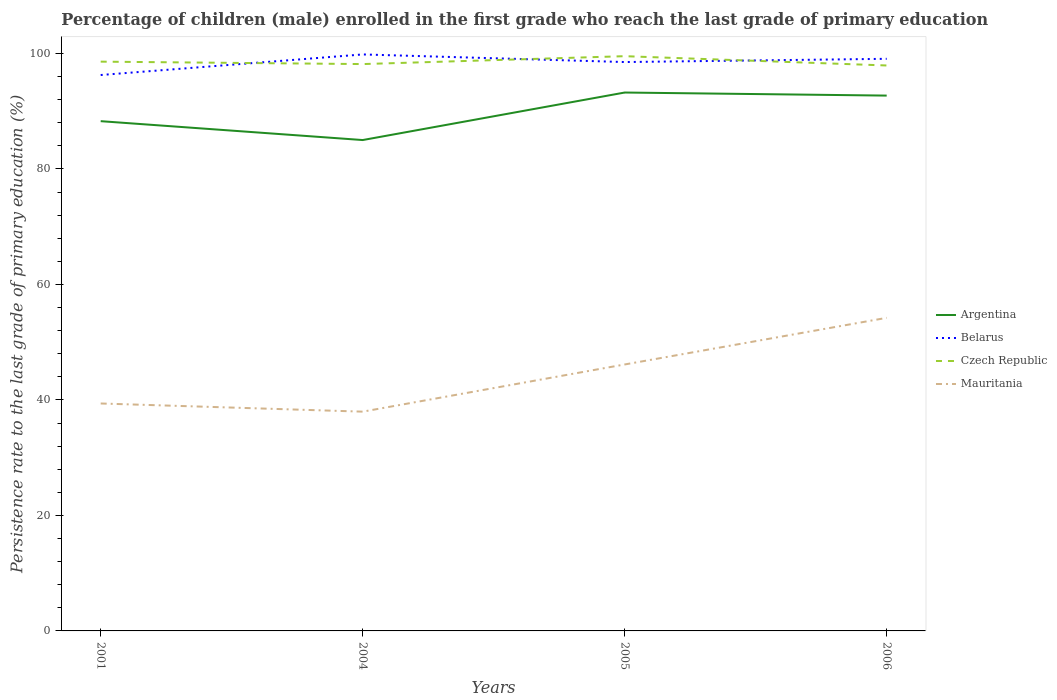How many different coloured lines are there?
Your response must be concise. 4. Does the line corresponding to Czech Republic intersect with the line corresponding to Argentina?
Your answer should be very brief. No. Across all years, what is the maximum persistence rate of children in Belarus?
Your response must be concise. 96.27. In which year was the persistence rate of children in Argentina maximum?
Offer a terse response. 2004. What is the total persistence rate of children in Argentina in the graph?
Your answer should be compact. -7.7. What is the difference between the highest and the second highest persistence rate of children in Mauritania?
Give a very brief answer. 16.25. What is the difference between the highest and the lowest persistence rate of children in Belarus?
Offer a very short reply. 3. How many lines are there?
Your response must be concise. 4. What is the difference between two consecutive major ticks on the Y-axis?
Give a very brief answer. 20. Does the graph contain any zero values?
Your answer should be very brief. No. Does the graph contain grids?
Offer a terse response. No. How many legend labels are there?
Keep it short and to the point. 4. What is the title of the graph?
Provide a short and direct response. Percentage of children (male) enrolled in the first grade who reach the last grade of primary education. Does "Japan" appear as one of the legend labels in the graph?
Provide a succinct answer. No. What is the label or title of the X-axis?
Provide a succinct answer. Years. What is the label or title of the Y-axis?
Provide a succinct answer. Persistence rate to the last grade of primary education (%). What is the Persistence rate to the last grade of primary education (%) of Argentina in 2001?
Offer a very short reply. 88.28. What is the Persistence rate to the last grade of primary education (%) in Belarus in 2001?
Provide a short and direct response. 96.27. What is the Persistence rate to the last grade of primary education (%) of Czech Republic in 2001?
Provide a succinct answer. 98.59. What is the Persistence rate to the last grade of primary education (%) of Mauritania in 2001?
Your answer should be very brief. 39.39. What is the Persistence rate to the last grade of primary education (%) in Argentina in 2004?
Your answer should be very brief. 85.01. What is the Persistence rate to the last grade of primary education (%) in Belarus in 2004?
Your answer should be compact. 99.84. What is the Persistence rate to the last grade of primary education (%) in Czech Republic in 2004?
Make the answer very short. 98.17. What is the Persistence rate to the last grade of primary education (%) of Mauritania in 2004?
Make the answer very short. 37.97. What is the Persistence rate to the last grade of primary education (%) in Argentina in 2005?
Ensure brevity in your answer.  93.24. What is the Persistence rate to the last grade of primary education (%) of Belarus in 2005?
Give a very brief answer. 98.52. What is the Persistence rate to the last grade of primary education (%) of Czech Republic in 2005?
Your response must be concise. 99.53. What is the Persistence rate to the last grade of primary education (%) in Mauritania in 2005?
Offer a very short reply. 46.14. What is the Persistence rate to the last grade of primary education (%) in Argentina in 2006?
Your answer should be very brief. 92.71. What is the Persistence rate to the last grade of primary education (%) in Belarus in 2006?
Your answer should be very brief. 99.08. What is the Persistence rate to the last grade of primary education (%) of Czech Republic in 2006?
Your answer should be compact. 97.92. What is the Persistence rate to the last grade of primary education (%) of Mauritania in 2006?
Your answer should be compact. 54.22. Across all years, what is the maximum Persistence rate to the last grade of primary education (%) of Argentina?
Provide a succinct answer. 93.24. Across all years, what is the maximum Persistence rate to the last grade of primary education (%) in Belarus?
Your response must be concise. 99.84. Across all years, what is the maximum Persistence rate to the last grade of primary education (%) of Czech Republic?
Make the answer very short. 99.53. Across all years, what is the maximum Persistence rate to the last grade of primary education (%) of Mauritania?
Your answer should be very brief. 54.22. Across all years, what is the minimum Persistence rate to the last grade of primary education (%) of Argentina?
Provide a succinct answer. 85.01. Across all years, what is the minimum Persistence rate to the last grade of primary education (%) in Belarus?
Offer a very short reply. 96.27. Across all years, what is the minimum Persistence rate to the last grade of primary education (%) of Czech Republic?
Offer a terse response. 97.92. Across all years, what is the minimum Persistence rate to the last grade of primary education (%) in Mauritania?
Offer a terse response. 37.97. What is the total Persistence rate to the last grade of primary education (%) in Argentina in the graph?
Offer a terse response. 359.23. What is the total Persistence rate to the last grade of primary education (%) in Belarus in the graph?
Make the answer very short. 393.7. What is the total Persistence rate to the last grade of primary education (%) of Czech Republic in the graph?
Offer a very short reply. 394.21. What is the total Persistence rate to the last grade of primary education (%) in Mauritania in the graph?
Offer a terse response. 177.73. What is the difference between the Persistence rate to the last grade of primary education (%) in Argentina in 2001 and that in 2004?
Ensure brevity in your answer.  3.27. What is the difference between the Persistence rate to the last grade of primary education (%) of Belarus in 2001 and that in 2004?
Offer a terse response. -3.56. What is the difference between the Persistence rate to the last grade of primary education (%) in Czech Republic in 2001 and that in 2004?
Offer a terse response. 0.42. What is the difference between the Persistence rate to the last grade of primary education (%) in Mauritania in 2001 and that in 2004?
Provide a short and direct response. 1.41. What is the difference between the Persistence rate to the last grade of primary education (%) in Argentina in 2001 and that in 2005?
Give a very brief answer. -4.96. What is the difference between the Persistence rate to the last grade of primary education (%) of Belarus in 2001 and that in 2005?
Provide a short and direct response. -2.25. What is the difference between the Persistence rate to the last grade of primary education (%) of Czech Republic in 2001 and that in 2005?
Provide a short and direct response. -0.95. What is the difference between the Persistence rate to the last grade of primary education (%) of Mauritania in 2001 and that in 2005?
Offer a very short reply. -6.76. What is the difference between the Persistence rate to the last grade of primary education (%) in Argentina in 2001 and that in 2006?
Your answer should be very brief. -4.43. What is the difference between the Persistence rate to the last grade of primary education (%) in Belarus in 2001 and that in 2006?
Ensure brevity in your answer.  -2.81. What is the difference between the Persistence rate to the last grade of primary education (%) of Czech Republic in 2001 and that in 2006?
Give a very brief answer. 0.66. What is the difference between the Persistence rate to the last grade of primary education (%) of Mauritania in 2001 and that in 2006?
Your answer should be very brief. -14.83. What is the difference between the Persistence rate to the last grade of primary education (%) in Argentina in 2004 and that in 2005?
Offer a very short reply. -8.23. What is the difference between the Persistence rate to the last grade of primary education (%) in Belarus in 2004 and that in 2005?
Keep it short and to the point. 1.32. What is the difference between the Persistence rate to the last grade of primary education (%) of Czech Republic in 2004 and that in 2005?
Keep it short and to the point. -1.37. What is the difference between the Persistence rate to the last grade of primary education (%) of Mauritania in 2004 and that in 2005?
Offer a very short reply. -8.17. What is the difference between the Persistence rate to the last grade of primary education (%) in Argentina in 2004 and that in 2006?
Give a very brief answer. -7.7. What is the difference between the Persistence rate to the last grade of primary education (%) in Belarus in 2004 and that in 2006?
Give a very brief answer. 0.76. What is the difference between the Persistence rate to the last grade of primary education (%) of Czech Republic in 2004 and that in 2006?
Offer a terse response. 0.24. What is the difference between the Persistence rate to the last grade of primary education (%) in Mauritania in 2004 and that in 2006?
Offer a very short reply. -16.25. What is the difference between the Persistence rate to the last grade of primary education (%) in Argentina in 2005 and that in 2006?
Your answer should be very brief. 0.53. What is the difference between the Persistence rate to the last grade of primary education (%) of Belarus in 2005 and that in 2006?
Keep it short and to the point. -0.56. What is the difference between the Persistence rate to the last grade of primary education (%) in Czech Republic in 2005 and that in 2006?
Offer a terse response. 1.61. What is the difference between the Persistence rate to the last grade of primary education (%) in Mauritania in 2005 and that in 2006?
Make the answer very short. -8.08. What is the difference between the Persistence rate to the last grade of primary education (%) of Argentina in 2001 and the Persistence rate to the last grade of primary education (%) of Belarus in 2004?
Offer a very short reply. -11.56. What is the difference between the Persistence rate to the last grade of primary education (%) of Argentina in 2001 and the Persistence rate to the last grade of primary education (%) of Czech Republic in 2004?
Keep it short and to the point. -9.89. What is the difference between the Persistence rate to the last grade of primary education (%) of Argentina in 2001 and the Persistence rate to the last grade of primary education (%) of Mauritania in 2004?
Provide a succinct answer. 50.3. What is the difference between the Persistence rate to the last grade of primary education (%) of Belarus in 2001 and the Persistence rate to the last grade of primary education (%) of Czech Republic in 2004?
Your answer should be very brief. -1.89. What is the difference between the Persistence rate to the last grade of primary education (%) of Belarus in 2001 and the Persistence rate to the last grade of primary education (%) of Mauritania in 2004?
Your answer should be very brief. 58.3. What is the difference between the Persistence rate to the last grade of primary education (%) in Czech Republic in 2001 and the Persistence rate to the last grade of primary education (%) in Mauritania in 2004?
Keep it short and to the point. 60.61. What is the difference between the Persistence rate to the last grade of primary education (%) in Argentina in 2001 and the Persistence rate to the last grade of primary education (%) in Belarus in 2005?
Your answer should be very brief. -10.24. What is the difference between the Persistence rate to the last grade of primary education (%) of Argentina in 2001 and the Persistence rate to the last grade of primary education (%) of Czech Republic in 2005?
Make the answer very short. -11.26. What is the difference between the Persistence rate to the last grade of primary education (%) of Argentina in 2001 and the Persistence rate to the last grade of primary education (%) of Mauritania in 2005?
Ensure brevity in your answer.  42.13. What is the difference between the Persistence rate to the last grade of primary education (%) in Belarus in 2001 and the Persistence rate to the last grade of primary education (%) in Czech Republic in 2005?
Your answer should be compact. -3.26. What is the difference between the Persistence rate to the last grade of primary education (%) in Belarus in 2001 and the Persistence rate to the last grade of primary education (%) in Mauritania in 2005?
Offer a very short reply. 50.13. What is the difference between the Persistence rate to the last grade of primary education (%) in Czech Republic in 2001 and the Persistence rate to the last grade of primary education (%) in Mauritania in 2005?
Provide a short and direct response. 52.44. What is the difference between the Persistence rate to the last grade of primary education (%) in Argentina in 2001 and the Persistence rate to the last grade of primary education (%) in Belarus in 2006?
Provide a short and direct response. -10.8. What is the difference between the Persistence rate to the last grade of primary education (%) in Argentina in 2001 and the Persistence rate to the last grade of primary education (%) in Czech Republic in 2006?
Offer a very short reply. -9.65. What is the difference between the Persistence rate to the last grade of primary education (%) of Argentina in 2001 and the Persistence rate to the last grade of primary education (%) of Mauritania in 2006?
Make the answer very short. 34.06. What is the difference between the Persistence rate to the last grade of primary education (%) in Belarus in 2001 and the Persistence rate to the last grade of primary education (%) in Czech Republic in 2006?
Make the answer very short. -1.65. What is the difference between the Persistence rate to the last grade of primary education (%) in Belarus in 2001 and the Persistence rate to the last grade of primary education (%) in Mauritania in 2006?
Your answer should be compact. 42.05. What is the difference between the Persistence rate to the last grade of primary education (%) in Czech Republic in 2001 and the Persistence rate to the last grade of primary education (%) in Mauritania in 2006?
Provide a succinct answer. 44.37. What is the difference between the Persistence rate to the last grade of primary education (%) of Argentina in 2004 and the Persistence rate to the last grade of primary education (%) of Belarus in 2005?
Provide a short and direct response. -13.51. What is the difference between the Persistence rate to the last grade of primary education (%) of Argentina in 2004 and the Persistence rate to the last grade of primary education (%) of Czech Republic in 2005?
Provide a succinct answer. -14.52. What is the difference between the Persistence rate to the last grade of primary education (%) of Argentina in 2004 and the Persistence rate to the last grade of primary education (%) of Mauritania in 2005?
Provide a succinct answer. 38.86. What is the difference between the Persistence rate to the last grade of primary education (%) in Belarus in 2004 and the Persistence rate to the last grade of primary education (%) in Czech Republic in 2005?
Provide a short and direct response. 0.3. What is the difference between the Persistence rate to the last grade of primary education (%) in Belarus in 2004 and the Persistence rate to the last grade of primary education (%) in Mauritania in 2005?
Your answer should be compact. 53.69. What is the difference between the Persistence rate to the last grade of primary education (%) in Czech Republic in 2004 and the Persistence rate to the last grade of primary education (%) in Mauritania in 2005?
Your response must be concise. 52.02. What is the difference between the Persistence rate to the last grade of primary education (%) in Argentina in 2004 and the Persistence rate to the last grade of primary education (%) in Belarus in 2006?
Give a very brief answer. -14.07. What is the difference between the Persistence rate to the last grade of primary education (%) of Argentina in 2004 and the Persistence rate to the last grade of primary education (%) of Czech Republic in 2006?
Your answer should be very brief. -12.91. What is the difference between the Persistence rate to the last grade of primary education (%) of Argentina in 2004 and the Persistence rate to the last grade of primary education (%) of Mauritania in 2006?
Keep it short and to the point. 30.79. What is the difference between the Persistence rate to the last grade of primary education (%) of Belarus in 2004 and the Persistence rate to the last grade of primary education (%) of Czech Republic in 2006?
Offer a very short reply. 1.91. What is the difference between the Persistence rate to the last grade of primary education (%) in Belarus in 2004 and the Persistence rate to the last grade of primary education (%) in Mauritania in 2006?
Provide a short and direct response. 45.61. What is the difference between the Persistence rate to the last grade of primary education (%) in Czech Republic in 2004 and the Persistence rate to the last grade of primary education (%) in Mauritania in 2006?
Your response must be concise. 43.95. What is the difference between the Persistence rate to the last grade of primary education (%) in Argentina in 2005 and the Persistence rate to the last grade of primary education (%) in Belarus in 2006?
Offer a very short reply. -5.84. What is the difference between the Persistence rate to the last grade of primary education (%) in Argentina in 2005 and the Persistence rate to the last grade of primary education (%) in Czech Republic in 2006?
Keep it short and to the point. -4.68. What is the difference between the Persistence rate to the last grade of primary education (%) of Argentina in 2005 and the Persistence rate to the last grade of primary education (%) of Mauritania in 2006?
Your answer should be very brief. 39.02. What is the difference between the Persistence rate to the last grade of primary education (%) in Belarus in 2005 and the Persistence rate to the last grade of primary education (%) in Czech Republic in 2006?
Ensure brevity in your answer.  0.59. What is the difference between the Persistence rate to the last grade of primary education (%) in Belarus in 2005 and the Persistence rate to the last grade of primary education (%) in Mauritania in 2006?
Your response must be concise. 44.3. What is the difference between the Persistence rate to the last grade of primary education (%) of Czech Republic in 2005 and the Persistence rate to the last grade of primary education (%) of Mauritania in 2006?
Offer a terse response. 45.31. What is the average Persistence rate to the last grade of primary education (%) in Argentina per year?
Offer a terse response. 89.81. What is the average Persistence rate to the last grade of primary education (%) of Belarus per year?
Ensure brevity in your answer.  98.43. What is the average Persistence rate to the last grade of primary education (%) of Czech Republic per year?
Your response must be concise. 98.55. What is the average Persistence rate to the last grade of primary education (%) of Mauritania per year?
Offer a terse response. 44.43. In the year 2001, what is the difference between the Persistence rate to the last grade of primary education (%) in Argentina and Persistence rate to the last grade of primary education (%) in Belarus?
Your response must be concise. -7.99. In the year 2001, what is the difference between the Persistence rate to the last grade of primary education (%) in Argentina and Persistence rate to the last grade of primary education (%) in Czech Republic?
Your answer should be very brief. -10.31. In the year 2001, what is the difference between the Persistence rate to the last grade of primary education (%) of Argentina and Persistence rate to the last grade of primary education (%) of Mauritania?
Provide a succinct answer. 48.89. In the year 2001, what is the difference between the Persistence rate to the last grade of primary education (%) of Belarus and Persistence rate to the last grade of primary education (%) of Czech Republic?
Provide a short and direct response. -2.31. In the year 2001, what is the difference between the Persistence rate to the last grade of primary education (%) of Belarus and Persistence rate to the last grade of primary education (%) of Mauritania?
Give a very brief answer. 56.88. In the year 2001, what is the difference between the Persistence rate to the last grade of primary education (%) of Czech Republic and Persistence rate to the last grade of primary education (%) of Mauritania?
Your answer should be very brief. 59.2. In the year 2004, what is the difference between the Persistence rate to the last grade of primary education (%) in Argentina and Persistence rate to the last grade of primary education (%) in Belarus?
Provide a succinct answer. -14.83. In the year 2004, what is the difference between the Persistence rate to the last grade of primary education (%) in Argentina and Persistence rate to the last grade of primary education (%) in Czech Republic?
Your answer should be compact. -13.16. In the year 2004, what is the difference between the Persistence rate to the last grade of primary education (%) of Argentina and Persistence rate to the last grade of primary education (%) of Mauritania?
Give a very brief answer. 47.04. In the year 2004, what is the difference between the Persistence rate to the last grade of primary education (%) in Belarus and Persistence rate to the last grade of primary education (%) in Czech Republic?
Offer a terse response. 1.67. In the year 2004, what is the difference between the Persistence rate to the last grade of primary education (%) of Belarus and Persistence rate to the last grade of primary education (%) of Mauritania?
Your response must be concise. 61.86. In the year 2004, what is the difference between the Persistence rate to the last grade of primary education (%) of Czech Republic and Persistence rate to the last grade of primary education (%) of Mauritania?
Provide a short and direct response. 60.19. In the year 2005, what is the difference between the Persistence rate to the last grade of primary education (%) in Argentina and Persistence rate to the last grade of primary education (%) in Belarus?
Offer a very short reply. -5.28. In the year 2005, what is the difference between the Persistence rate to the last grade of primary education (%) in Argentina and Persistence rate to the last grade of primary education (%) in Czech Republic?
Your answer should be compact. -6.3. In the year 2005, what is the difference between the Persistence rate to the last grade of primary education (%) in Argentina and Persistence rate to the last grade of primary education (%) in Mauritania?
Keep it short and to the point. 47.09. In the year 2005, what is the difference between the Persistence rate to the last grade of primary education (%) of Belarus and Persistence rate to the last grade of primary education (%) of Czech Republic?
Give a very brief answer. -1.02. In the year 2005, what is the difference between the Persistence rate to the last grade of primary education (%) in Belarus and Persistence rate to the last grade of primary education (%) in Mauritania?
Offer a terse response. 52.37. In the year 2005, what is the difference between the Persistence rate to the last grade of primary education (%) in Czech Republic and Persistence rate to the last grade of primary education (%) in Mauritania?
Your response must be concise. 53.39. In the year 2006, what is the difference between the Persistence rate to the last grade of primary education (%) of Argentina and Persistence rate to the last grade of primary education (%) of Belarus?
Offer a very short reply. -6.37. In the year 2006, what is the difference between the Persistence rate to the last grade of primary education (%) in Argentina and Persistence rate to the last grade of primary education (%) in Czech Republic?
Provide a short and direct response. -5.22. In the year 2006, what is the difference between the Persistence rate to the last grade of primary education (%) of Argentina and Persistence rate to the last grade of primary education (%) of Mauritania?
Provide a short and direct response. 38.49. In the year 2006, what is the difference between the Persistence rate to the last grade of primary education (%) of Belarus and Persistence rate to the last grade of primary education (%) of Czech Republic?
Provide a succinct answer. 1.15. In the year 2006, what is the difference between the Persistence rate to the last grade of primary education (%) of Belarus and Persistence rate to the last grade of primary education (%) of Mauritania?
Make the answer very short. 44.86. In the year 2006, what is the difference between the Persistence rate to the last grade of primary education (%) in Czech Republic and Persistence rate to the last grade of primary education (%) in Mauritania?
Ensure brevity in your answer.  43.7. What is the ratio of the Persistence rate to the last grade of primary education (%) in Argentina in 2001 to that in 2004?
Make the answer very short. 1.04. What is the ratio of the Persistence rate to the last grade of primary education (%) of Mauritania in 2001 to that in 2004?
Your answer should be very brief. 1.04. What is the ratio of the Persistence rate to the last grade of primary education (%) in Argentina in 2001 to that in 2005?
Offer a very short reply. 0.95. What is the ratio of the Persistence rate to the last grade of primary education (%) in Belarus in 2001 to that in 2005?
Your answer should be very brief. 0.98. What is the ratio of the Persistence rate to the last grade of primary education (%) in Czech Republic in 2001 to that in 2005?
Your response must be concise. 0.99. What is the ratio of the Persistence rate to the last grade of primary education (%) in Mauritania in 2001 to that in 2005?
Keep it short and to the point. 0.85. What is the ratio of the Persistence rate to the last grade of primary education (%) in Argentina in 2001 to that in 2006?
Provide a succinct answer. 0.95. What is the ratio of the Persistence rate to the last grade of primary education (%) of Belarus in 2001 to that in 2006?
Ensure brevity in your answer.  0.97. What is the ratio of the Persistence rate to the last grade of primary education (%) of Czech Republic in 2001 to that in 2006?
Provide a short and direct response. 1.01. What is the ratio of the Persistence rate to the last grade of primary education (%) of Mauritania in 2001 to that in 2006?
Give a very brief answer. 0.73. What is the ratio of the Persistence rate to the last grade of primary education (%) of Argentina in 2004 to that in 2005?
Offer a terse response. 0.91. What is the ratio of the Persistence rate to the last grade of primary education (%) in Belarus in 2004 to that in 2005?
Provide a succinct answer. 1.01. What is the ratio of the Persistence rate to the last grade of primary education (%) in Czech Republic in 2004 to that in 2005?
Make the answer very short. 0.99. What is the ratio of the Persistence rate to the last grade of primary education (%) in Mauritania in 2004 to that in 2005?
Your answer should be very brief. 0.82. What is the ratio of the Persistence rate to the last grade of primary education (%) in Argentina in 2004 to that in 2006?
Ensure brevity in your answer.  0.92. What is the ratio of the Persistence rate to the last grade of primary education (%) in Belarus in 2004 to that in 2006?
Ensure brevity in your answer.  1.01. What is the ratio of the Persistence rate to the last grade of primary education (%) in Czech Republic in 2004 to that in 2006?
Your answer should be compact. 1. What is the ratio of the Persistence rate to the last grade of primary education (%) of Mauritania in 2004 to that in 2006?
Give a very brief answer. 0.7. What is the ratio of the Persistence rate to the last grade of primary education (%) of Argentina in 2005 to that in 2006?
Ensure brevity in your answer.  1.01. What is the ratio of the Persistence rate to the last grade of primary education (%) in Czech Republic in 2005 to that in 2006?
Keep it short and to the point. 1.02. What is the ratio of the Persistence rate to the last grade of primary education (%) of Mauritania in 2005 to that in 2006?
Give a very brief answer. 0.85. What is the difference between the highest and the second highest Persistence rate to the last grade of primary education (%) of Argentina?
Provide a short and direct response. 0.53. What is the difference between the highest and the second highest Persistence rate to the last grade of primary education (%) of Belarus?
Your answer should be very brief. 0.76. What is the difference between the highest and the second highest Persistence rate to the last grade of primary education (%) of Czech Republic?
Provide a succinct answer. 0.95. What is the difference between the highest and the second highest Persistence rate to the last grade of primary education (%) in Mauritania?
Your answer should be very brief. 8.08. What is the difference between the highest and the lowest Persistence rate to the last grade of primary education (%) of Argentina?
Give a very brief answer. 8.23. What is the difference between the highest and the lowest Persistence rate to the last grade of primary education (%) in Belarus?
Your answer should be compact. 3.56. What is the difference between the highest and the lowest Persistence rate to the last grade of primary education (%) in Czech Republic?
Make the answer very short. 1.61. What is the difference between the highest and the lowest Persistence rate to the last grade of primary education (%) in Mauritania?
Provide a short and direct response. 16.25. 